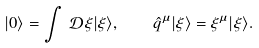Convert formula to latex. <formula><loc_0><loc_0><loc_500><loc_500>| 0 \rangle = \int \, \mathcal { D } \xi | \xi \rangle , \quad \hat { q } ^ { \mu } | \xi \rangle = \xi ^ { \mu } | \xi \rangle .</formula> 